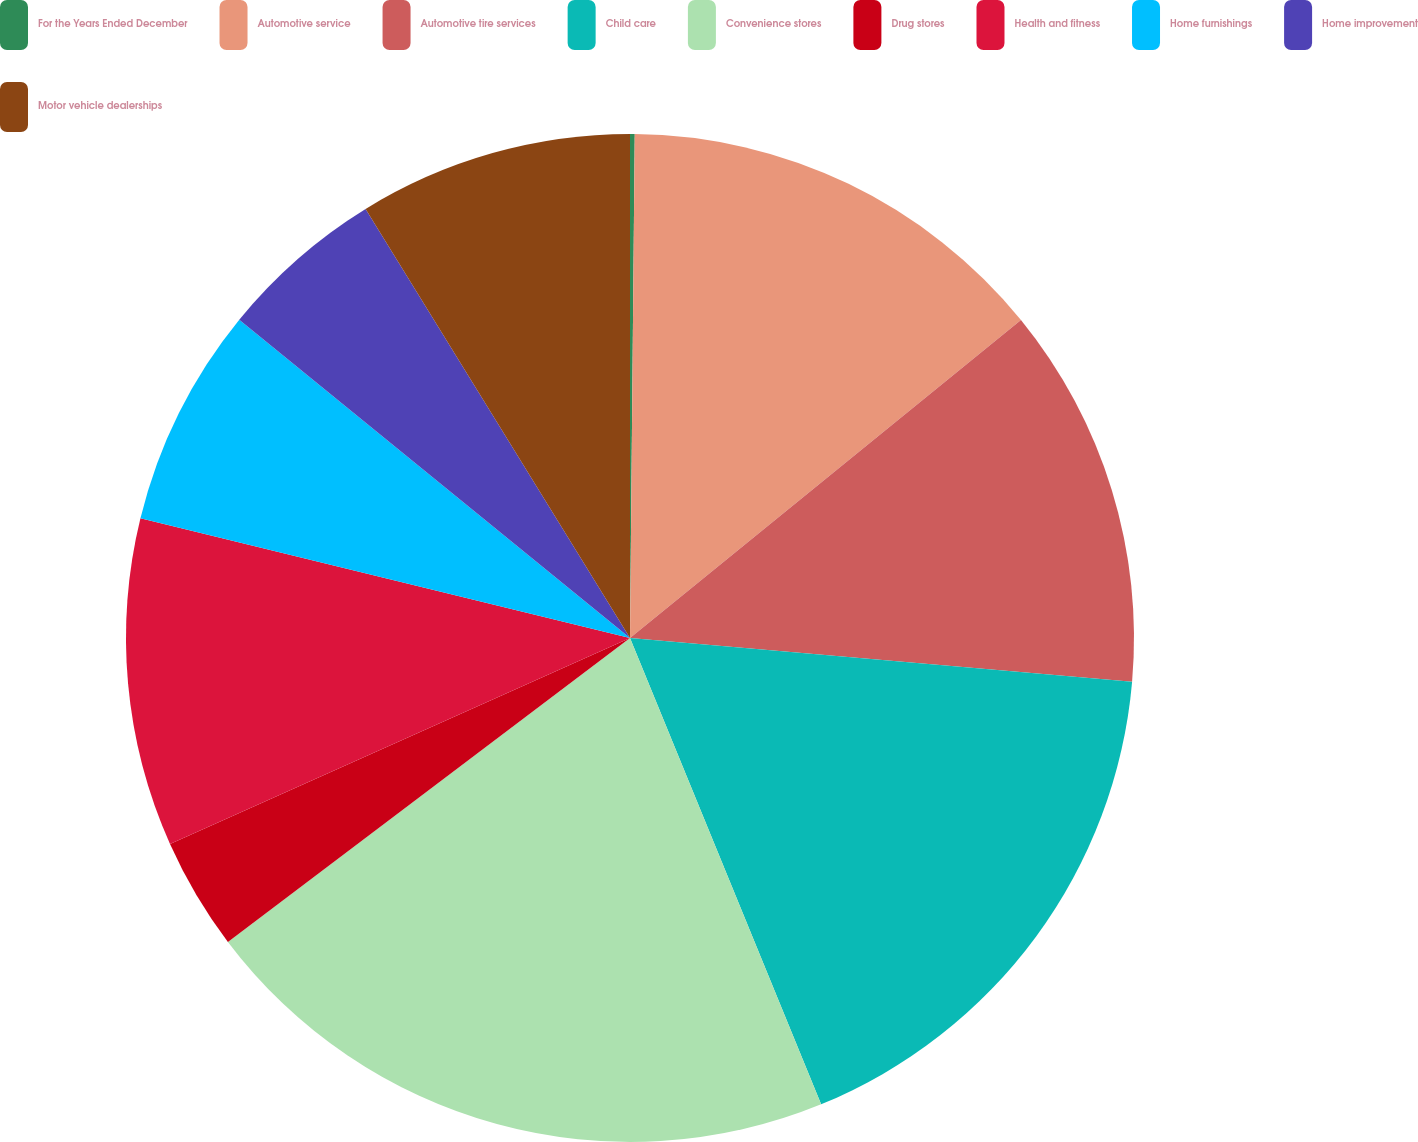Convert chart to OTSL. <chart><loc_0><loc_0><loc_500><loc_500><pie_chart><fcel>For the Years Ended December<fcel>Automotive service<fcel>Automotive tire services<fcel>Child care<fcel>Convenience stores<fcel>Drug stores<fcel>Health and fitness<fcel>Home furnishings<fcel>Home improvement<fcel>Motor vehicle dealerships<nl><fcel>0.15%<fcel>13.98%<fcel>12.25%<fcel>17.43%<fcel>20.89%<fcel>3.6%<fcel>10.52%<fcel>7.06%<fcel>5.33%<fcel>8.79%<nl></chart> 